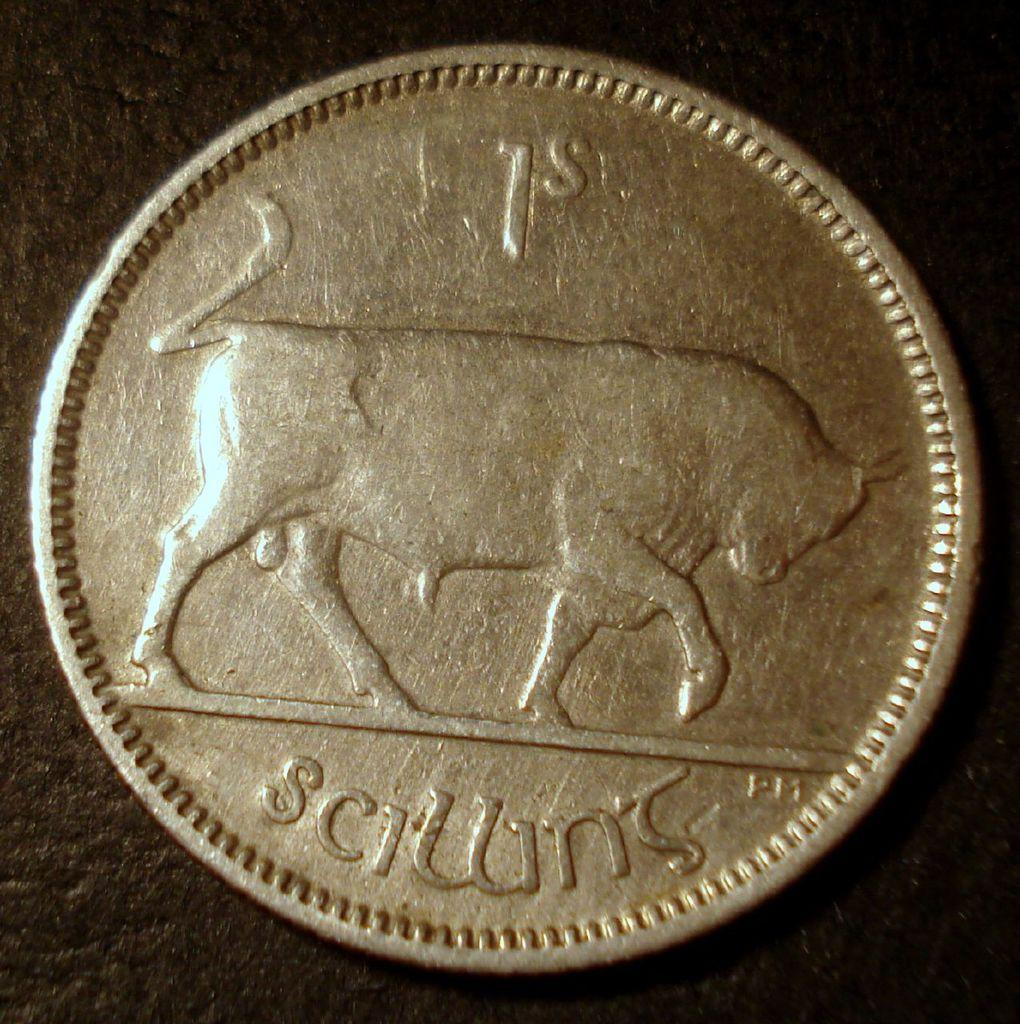<image>
Summarize the visual content of the image. the letter s is on a coin with a black background 